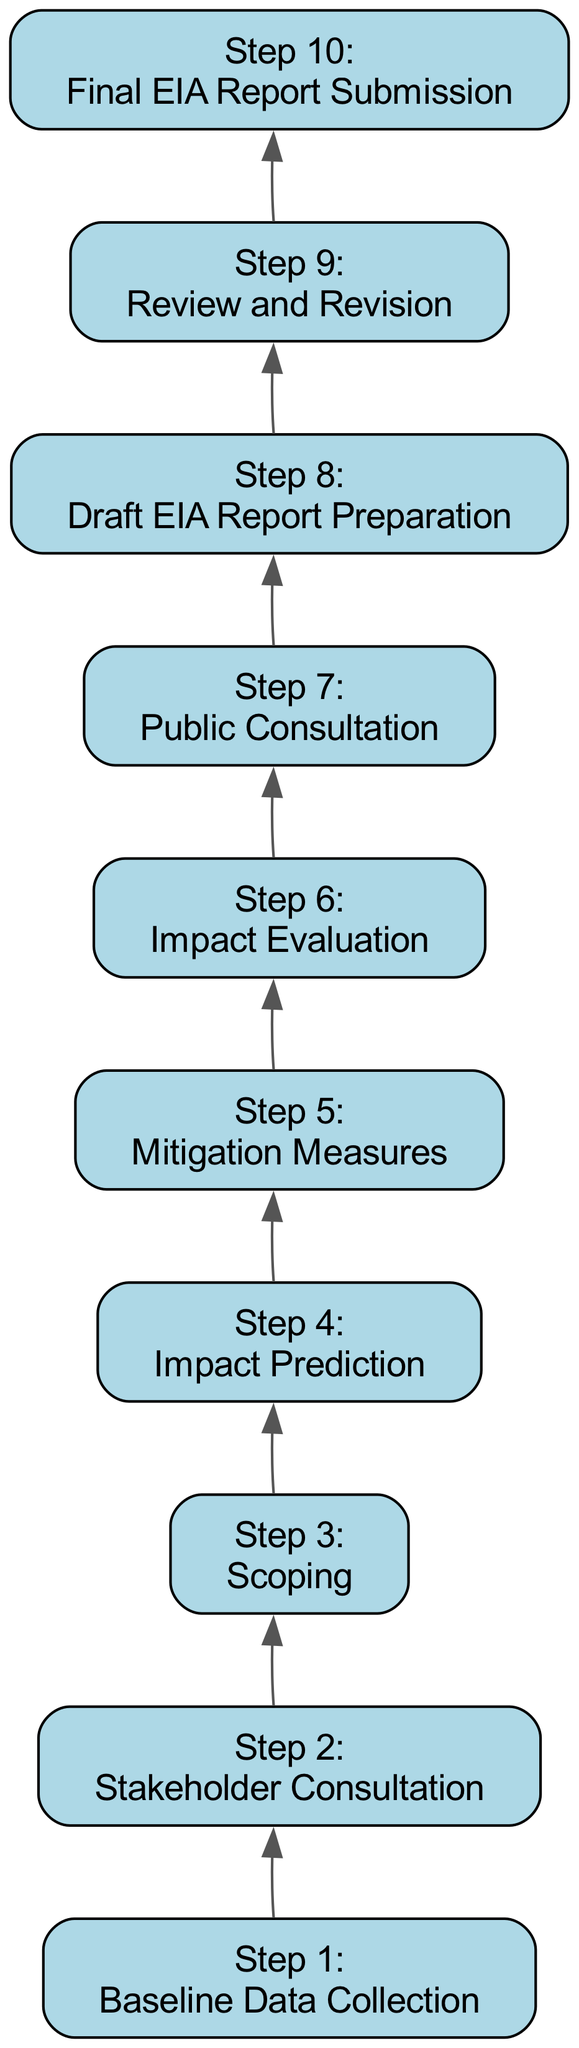What is the first step in the Environmental Impact Assessment process? The diagram indicates that the first step is "Baseline Data Collection," as it is the first node at the bottom of the flowchart.
Answer: Baseline Data Collection How many steps are there in total in the flowchart? By counting the number of distinct steps represented in the flowchart, there are a total of 10 steps, as listed in the nodes from bottom to top.
Answer: 10 What is the last step before the final report submission? By examining the flowchart, the step immediately preceding "Final EIA Report Submission" is "Review and Revision," which is connected directly above it.
Answer: Review and Revision Which step deals specifically with engaging local stakeholders? The flowchart clearly identifies "Stakeholder Consultation" as the step that involves engaging with local communities and stakeholders.
Answer: Stakeholder Consultation What is the main focus of the "Impact Evaluation" step? The "Impact Evaluation" step centers on assessing the significance of the predicted impacts and the effectiveness of mitigation measures using established criteria.
Answer: Assessing significance What is the relationship between "Impact Prediction" and "Mitigation Measures"? The flowchart indicates that after "Impact Prediction," the next step is "Mitigation Measures," implying that mitigation strategies are developed based on predicted impacts.
Answer: Mitigation Measures are based on predicted impacts Which step involves public engagement after the impact assessment process? The step labeled "Public Consultation" specifically mentions presenting findings to the public and stakeholders, indicating active engagement with them.
Answer: Public Consultation During which step is the draft EIA report prepared? The diagram specifies that the "Draft EIA Report Preparation" step is where all findings and predictions are compiled into a draft report.
Answer: Draft EIA Report Preparation What do the invisible edges in the diagram signify? The invisible edges are used to improve layout by helping to organize the flow of the diagram without showing an actual connection between the nodes.
Answer: Improve layout 